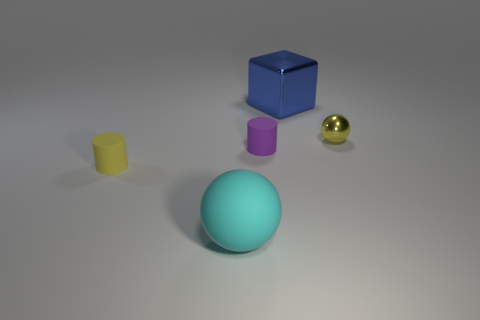What might the arrangement of shapes tell us about the use of space in design? The arrangement of shapes is balanced, with enough space between them to prevent clutter. This use of negative space emphasizes each object and creates a pleasing aesthetic. It demonstrates a principle of design where space is used deliberately to highlight individual elements and create a sense of organization. 